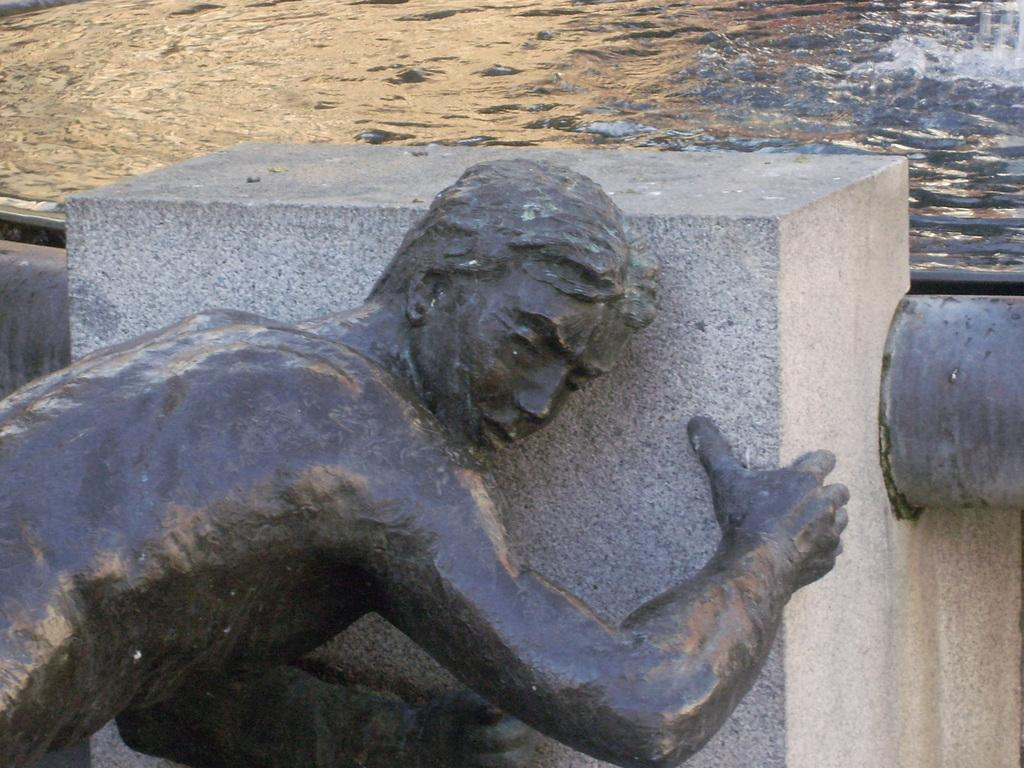What is the main subject in the image? There is a statue in the image. What other objects can be seen in the image? There is a stone and a pipe visible in the image. What can be seen in the background of the image? There is water visible in the background of the image. What type of doctor is standing next to the statue in the image? There is no doctor present in the image. The image only features a statue, a stone, a pipe, and water in the background. 